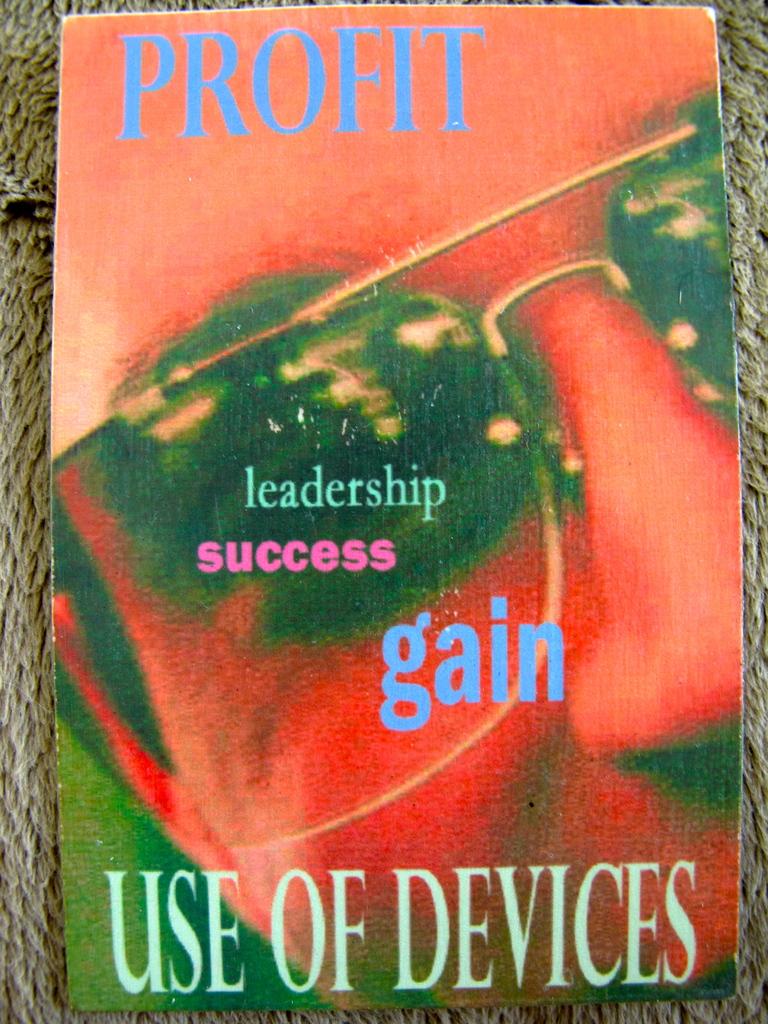What is the blue word at the top of the book?
Give a very brief answer. Profit. According to this book, use of what?
Provide a succinct answer. Devices. 